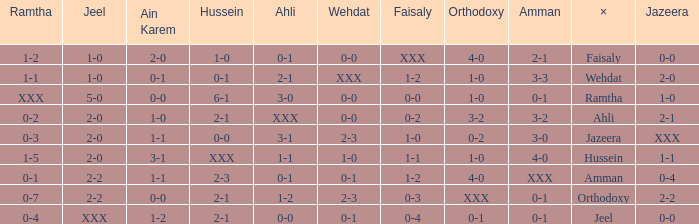What is x when faisaly is 0-0? Ramtha. 